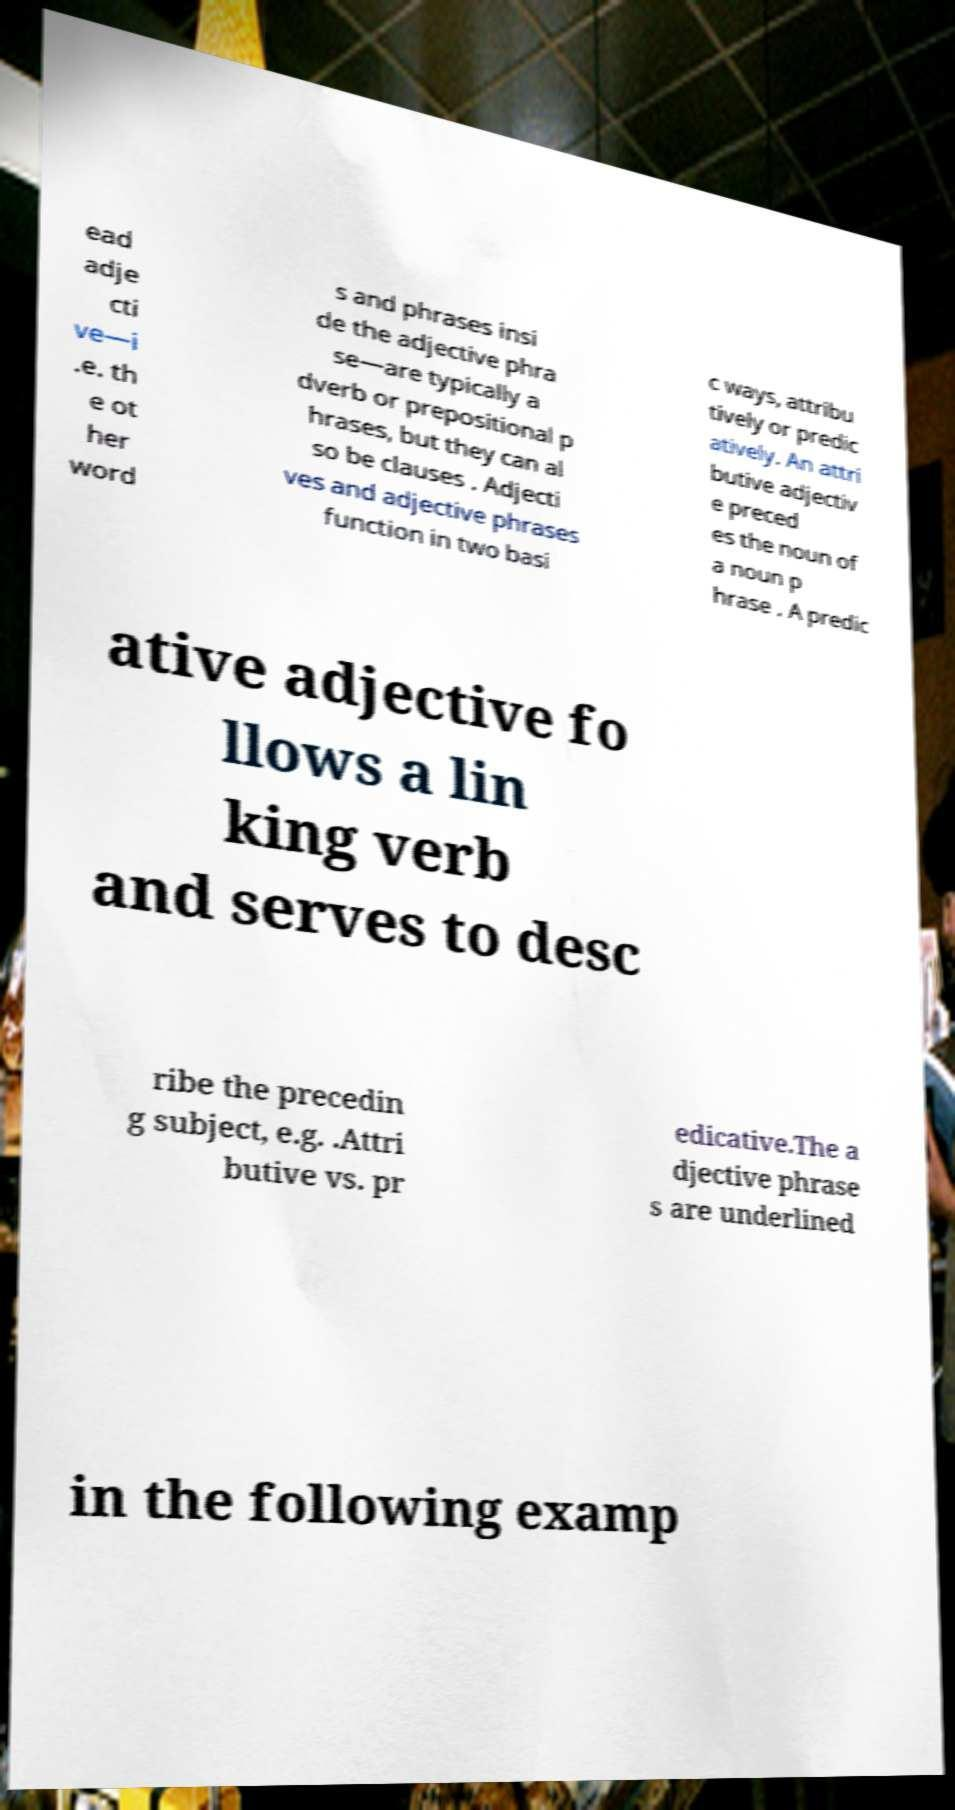For documentation purposes, I need the text within this image transcribed. Could you provide that? ead adje cti ve—i .e. th e ot her word s and phrases insi de the adjective phra se—are typically a dverb or prepositional p hrases, but they can al so be clauses . Adjecti ves and adjective phrases function in two basi c ways, attribu tively or predic atively. An attri butive adjectiv e preced es the noun of a noun p hrase . A predic ative adjective fo llows a lin king verb and serves to desc ribe the precedin g subject, e.g. .Attri butive vs. pr edicative.The a djective phrase s are underlined in the following examp 